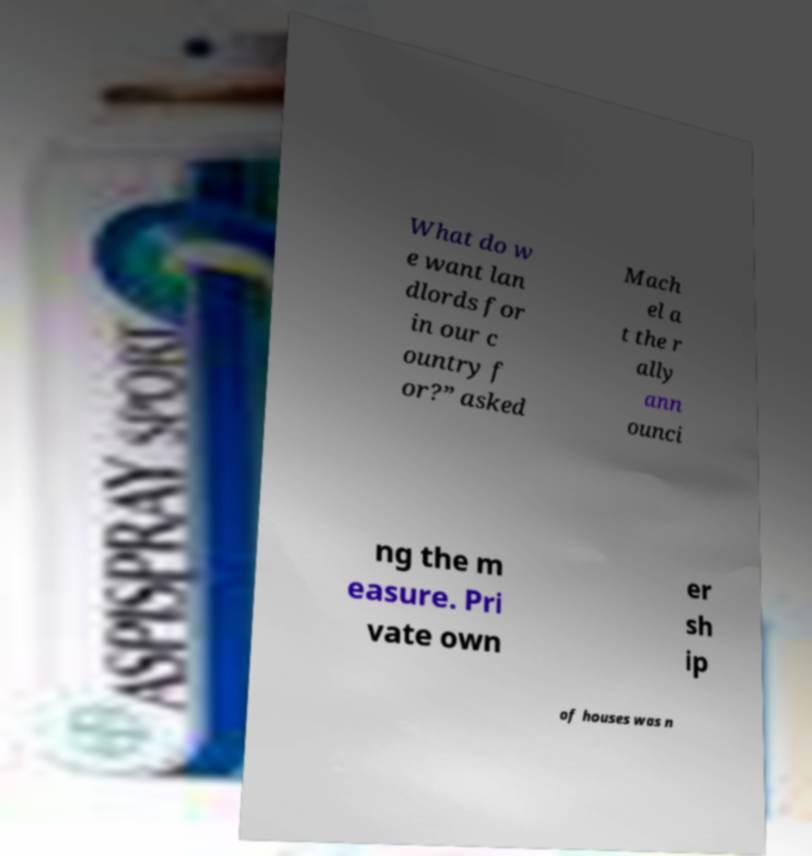Could you extract and type out the text from this image? What do w e want lan dlords for in our c ountry f or?” asked Mach el a t the r ally ann ounci ng the m easure. Pri vate own er sh ip of houses was n 